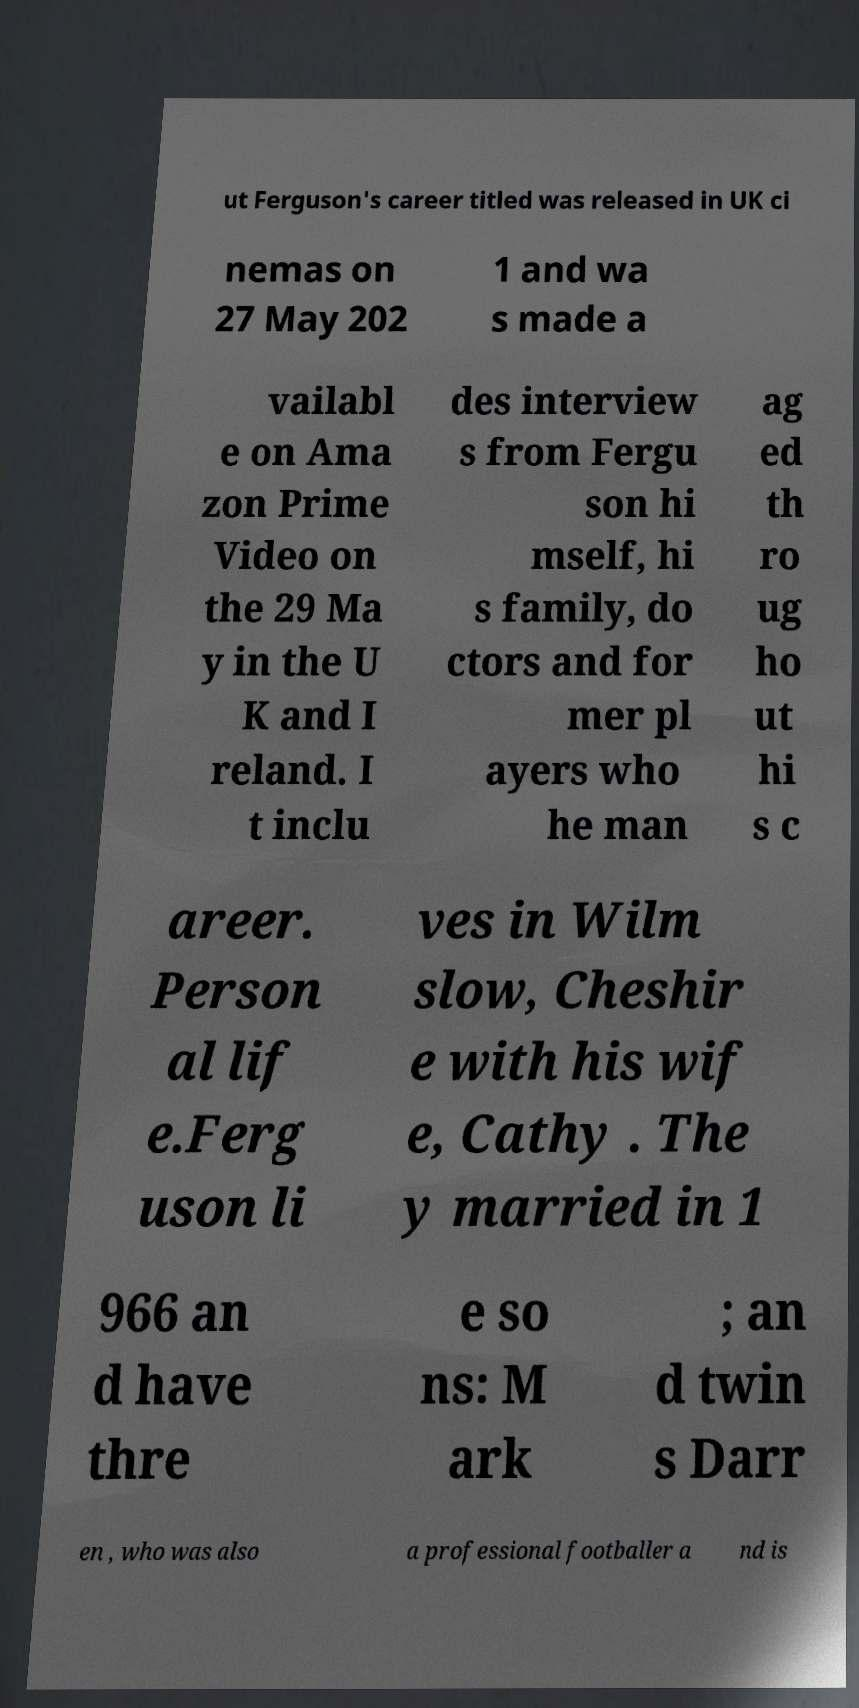I need the written content from this picture converted into text. Can you do that? ut Ferguson's career titled was released in UK ci nemas on 27 May 202 1 and wa s made a vailabl e on Ama zon Prime Video on the 29 Ma y in the U K and I reland. I t inclu des interview s from Fergu son hi mself, hi s family, do ctors and for mer pl ayers who he man ag ed th ro ug ho ut hi s c areer. Person al lif e.Ferg uson li ves in Wilm slow, Cheshir e with his wif e, Cathy . The y married in 1 966 an d have thre e so ns: M ark ; an d twin s Darr en , who was also a professional footballer a nd is 